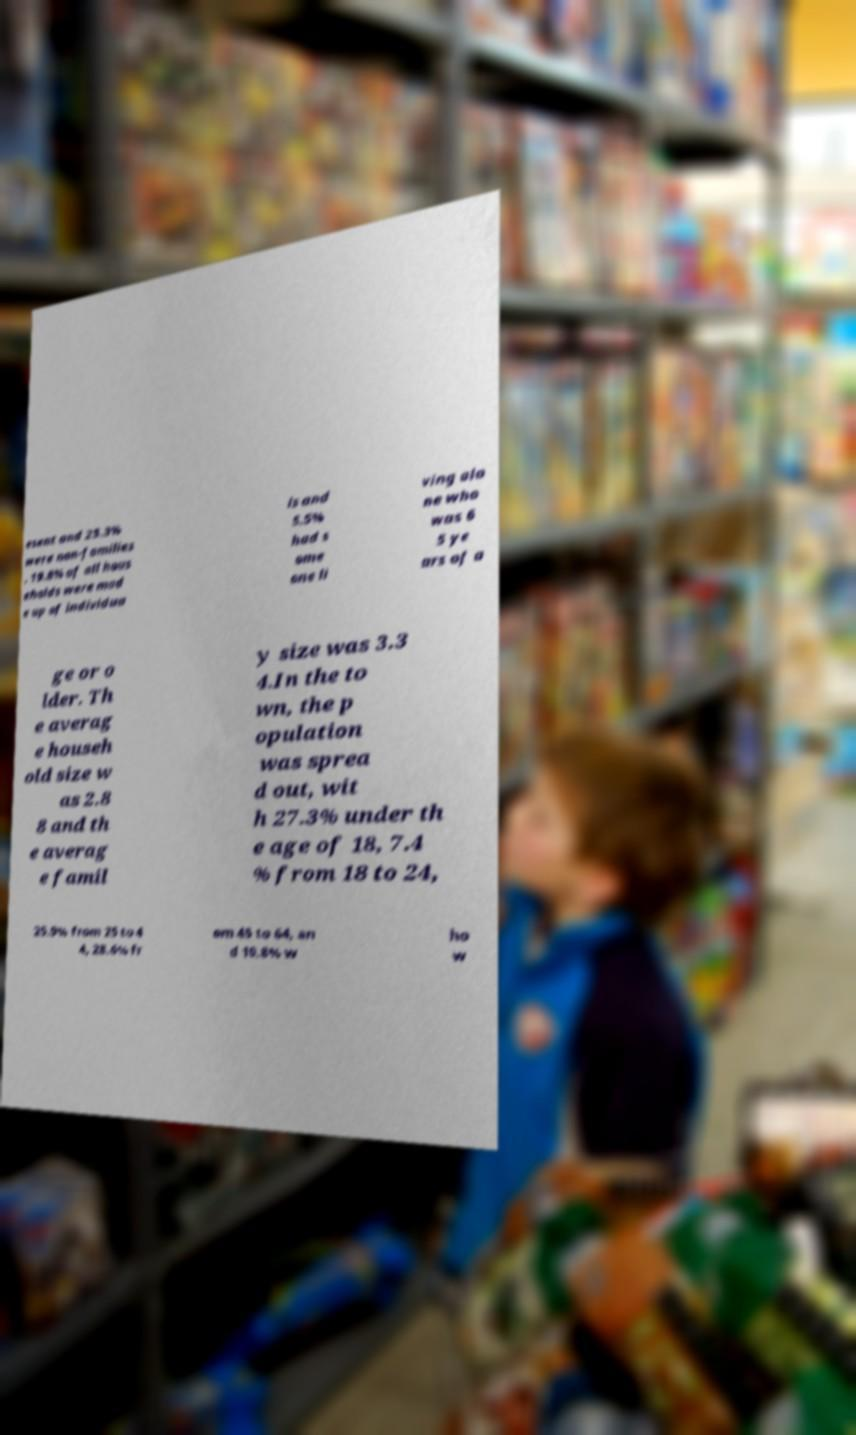Please identify and transcribe the text found in this image. esent and 25.3% were non-families . 19.8% of all hous eholds were mad e up of individua ls and 5.5% had s ome one li ving alo ne who was 6 5 ye ars of a ge or o lder. Th e averag e househ old size w as 2.8 8 and th e averag e famil y size was 3.3 4.In the to wn, the p opulation was sprea d out, wit h 27.3% under th e age of 18, 7.4 % from 18 to 24, 25.9% from 25 to 4 4, 28.6% fr om 45 to 64, an d 10.8% w ho w 